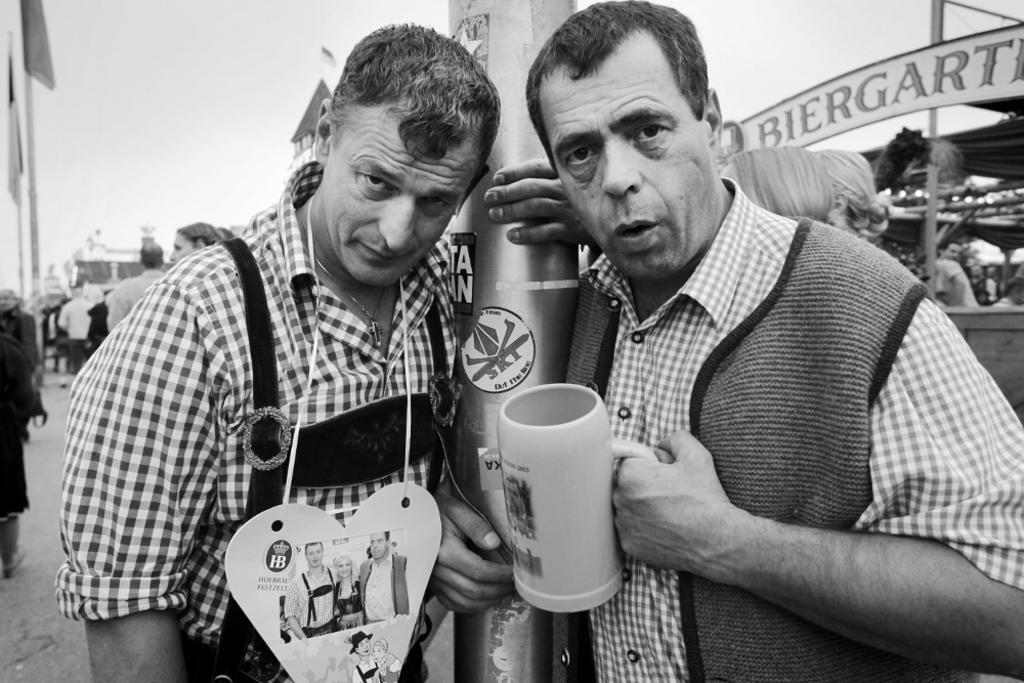Please provide a concise description of this image. A person on the right is holding a glass and standing. A person is holding a pillar and he is wearing a tag. In the back there are many people and name board. 